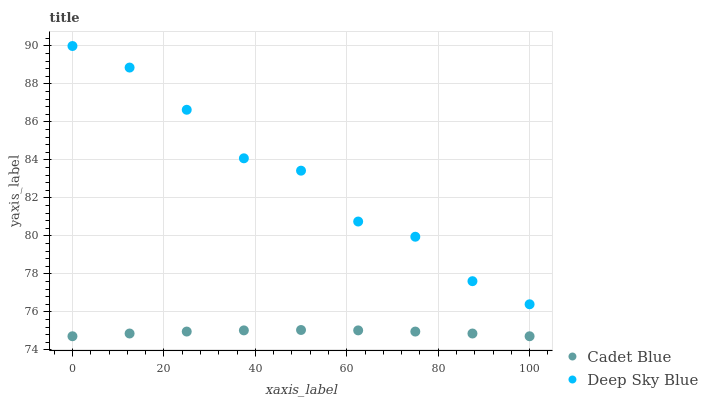Does Cadet Blue have the minimum area under the curve?
Answer yes or no. Yes. Does Deep Sky Blue have the maximum area under the curve?
Answer yes or no. Yes. Does Deep Sky Blue have the minimum area under the curve?
Answer yes or no. No. Is Cadet Blue the smoothest?
Answer yes or no. Yes. Is Deep Sky Blue the roughest?
Answer yes or no. Yes. Is Deep Sky Blue the smoothest?
Answer yes or no. No. Does Cadet Blue have the lowest value?
Answer yes or no. Yes. Does Deep Sky Blue have the lowest value?
Answer yes or no. No. Does Deep Sky Blue have the highest value?
Answer yes or no. Yes. Is Cadet Blue less than Deep Sky Blue?
Answer yes or no. Yes. Is Deep Sky Blue greater than Cadet Blue?
Answer yes or no. Yes. Does Cadet Blue intersect Deep Sky Blue?
Answer yes or no. No. 